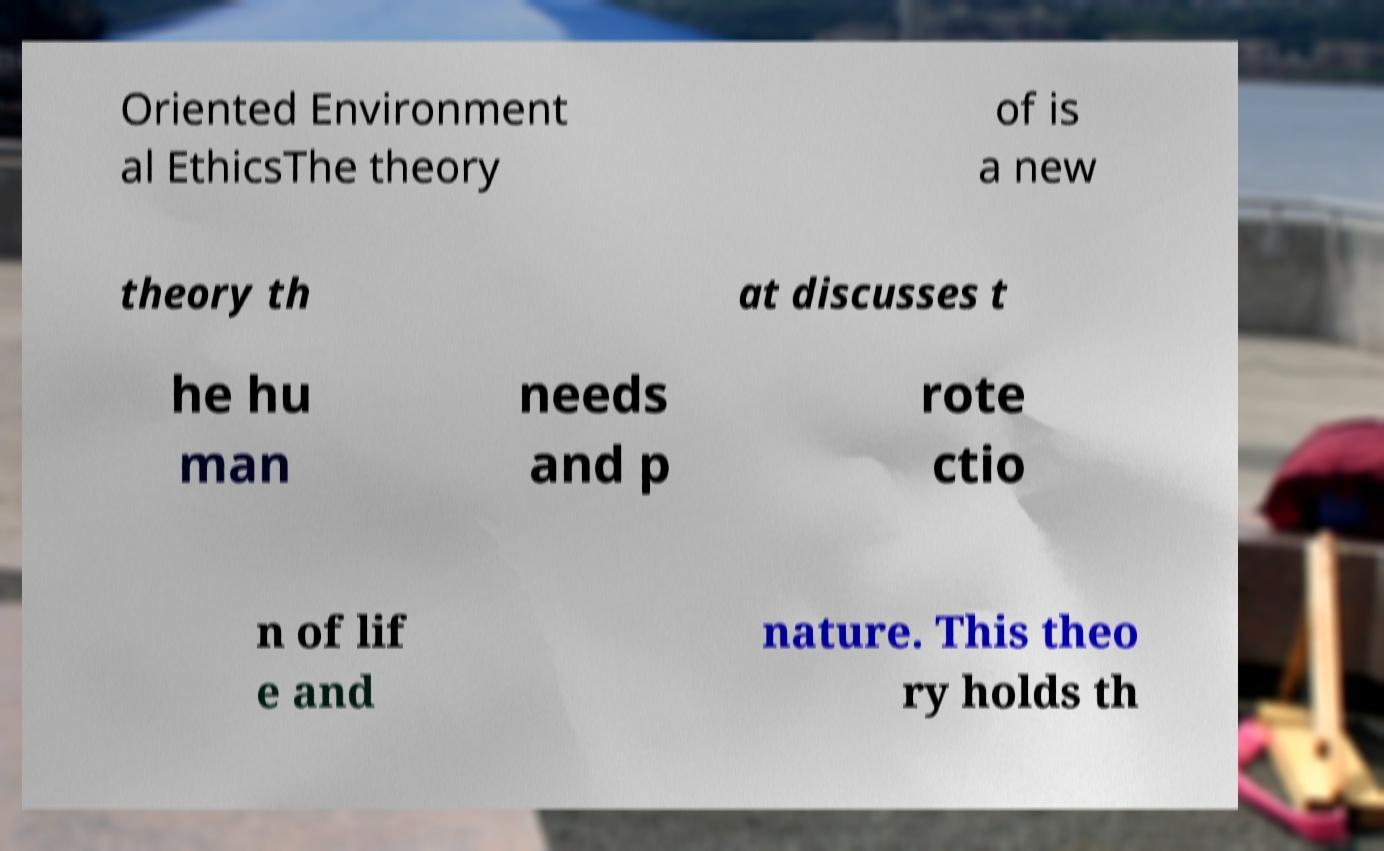I need the written content from this picture converted into text. Can you do that? Oriented Environment al EthicsThe theory of is a new theory th at discusses t he hu man needs and p rote ctio n of lif e and nature. This theo ry holds th 